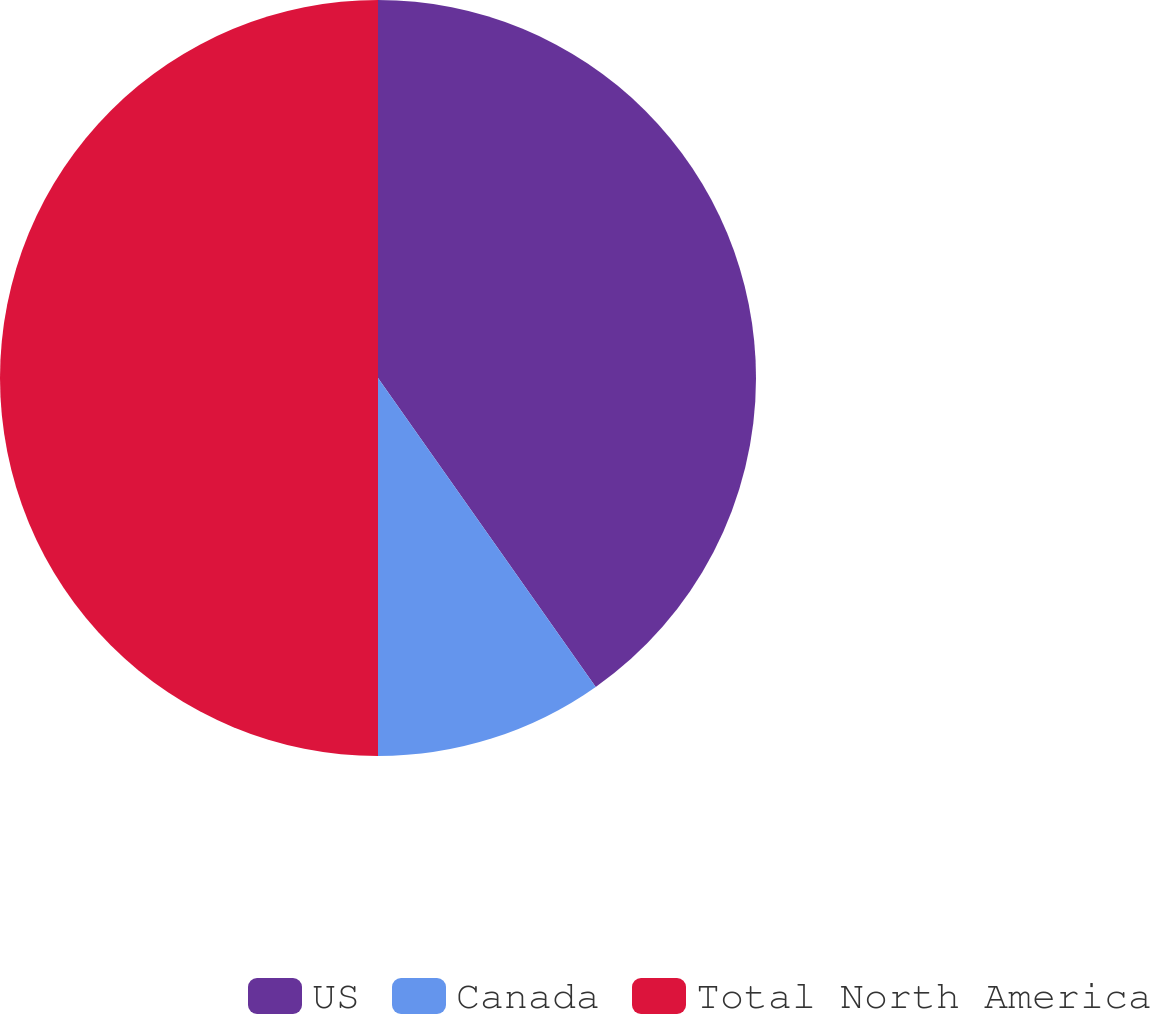Convert chart. <chart><loc_0><loc_0><loc_500><loc_500><pie_chart><fcel>US<fcel>Canada<fcel>Total North America<nl><fcel>40.23%<fcel>9.77%<fcel>50.0%<nl></chart> 